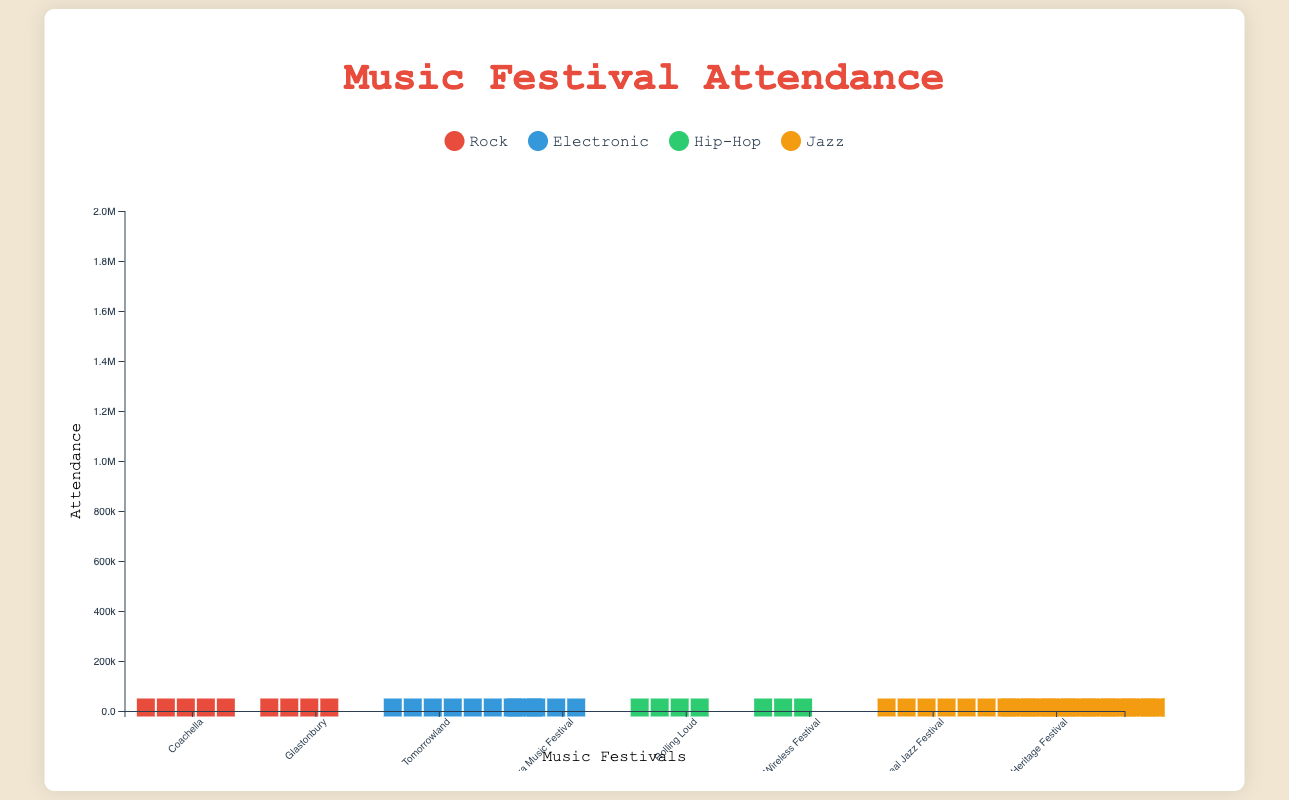What is the total attendance for all the Rock festivals? Sum the attendances of the Rock festivals: Coachella (250,000) + Glastonbury (200,000) = 450,000
Answer: 450,000 Which genre has the highest attendance in a single festival? Compare the highest attendance figures for each genre and find the maximum: Montreal Jazz Festival (2,000,000) has the highest attendance among others.
Answer: Jazz What is the average attendance for Hip-Hop festivals? Average the attendance of Hip-Hop festivals: (Rolling Loud 180,000 + Wireless Festival 135,000) / 2 = 157,500
Answer: 157,500 Which festival in California has the higher attendance and by how much? Compare the attendance for the California festivals: Coachella (250,000) and Rolling Loud (180,000), then find the difference: 250,000 - 180,000 = 70,000
Answer: Coachella by 70,000 What is the difference in attendance between the largest and smallest festivals? Find the attendance of the largest (Montreal Jazz Festival: 2,000,000) and smallest (Wireless Festival: 135,000) festivals, then subtract: 2,000,000 - 135,000 = 1,865,000
Answer: 1,865,000 What is the total attendance for all the festivals in England? Sum the attendances of festivals in England: Glastonbury (200,000) + Wireless Festival (135,000) = 335,000
Answer: 335,000 Which genre has the most festivals listed? Count the number of festivals listed for each genre: Rock (2), Electronic (2), Hip-Hop (2), Jazz (2). All have the same amount.
Answer: All genres have the same amount How does the attendance of Ultra Music Festival compare to the average attendance of Electronic festivals? Calculate the average attendance for Electronic festivals: (Tomorrowland 400,000 + Ultra Music Festival 165,000) / 2 = 282,500. Compare it to Ultra: 165,000 < 282,500
Answer: Less than average Which location has the highest overall attendance when combining all festivals held there? Sum the attendances for each location and determine the highest: California (250,000 + 180,000 = 430,000), England (200,000 + 135,000 = 335,000), Belgium (400,000), Florida (165,000), Canada (2,000,000), Louisiana (475,000). Canada has the highest with 2,000,000.
Answer: Canada Which Jazz festival has the lower attendance? Compare the attendances of Jazz festivals: Montreal Jazz Festival (2,000,000) and New Orleans Jazz & Heritage Festival (475,000). The latter is lower.
Answer: New Orleans Jazz & Heritage Festival 